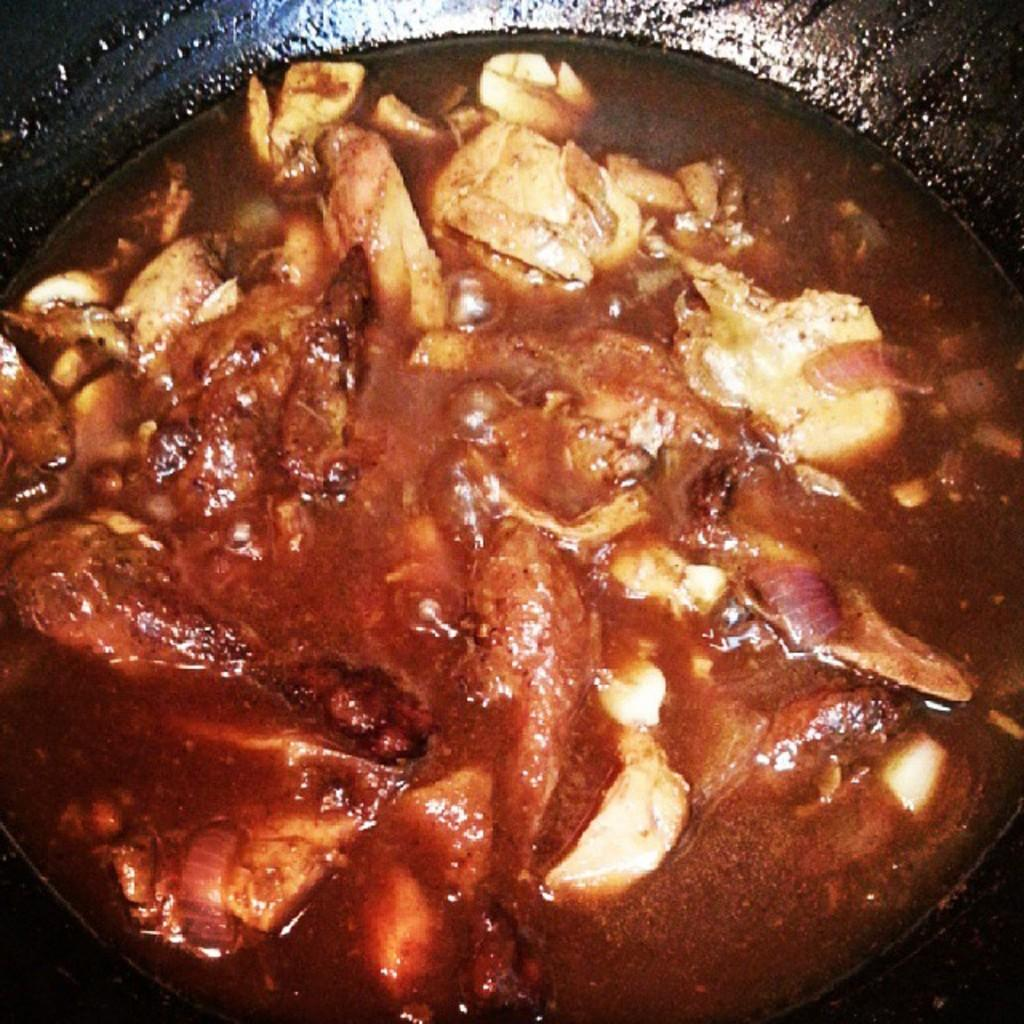What type of food is visible in the image? There is chicken curry in the image. In what type of container is the chicken curry placed? The chicken curry is in a black pan. What type of board is used to serve the chicken curry in the image? There is no board present in the image; the chicken curry is in a black pan. What kind of pet can be seen playing with the chicken curry in the image? There are no pets present in the image; it only features chicken curry in a black pan. 